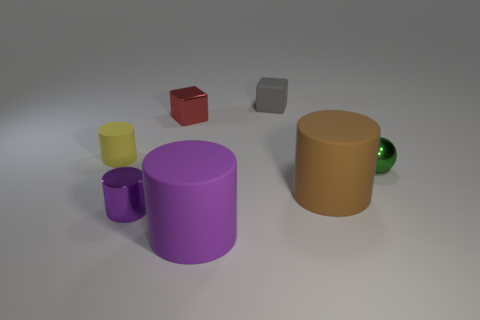Subtract all rubber cylinders. How many cylinders are left? 1 Add 1 tiny green metallic spheres. How many objects exist? 8 Subtract all purple cylinders. Subtract all brown blocks. How many cylinders are left? 2 Subtract all cyan blocks. How many red cylinders are left? 0 Subtract all matte cylinders. Subtract all tiny green spheres. How many objects are left? 3 Add 6 metal balls. How many metal balls are left? 7 Add 2 yellow matte objects. How many yellow matte objects exist? 3 Subtract all red blocks. How many blocks are left? 1 Subtract 0 blue balls. How many objects are left? 7 Subtract all blocks. How many objects are left? 5 